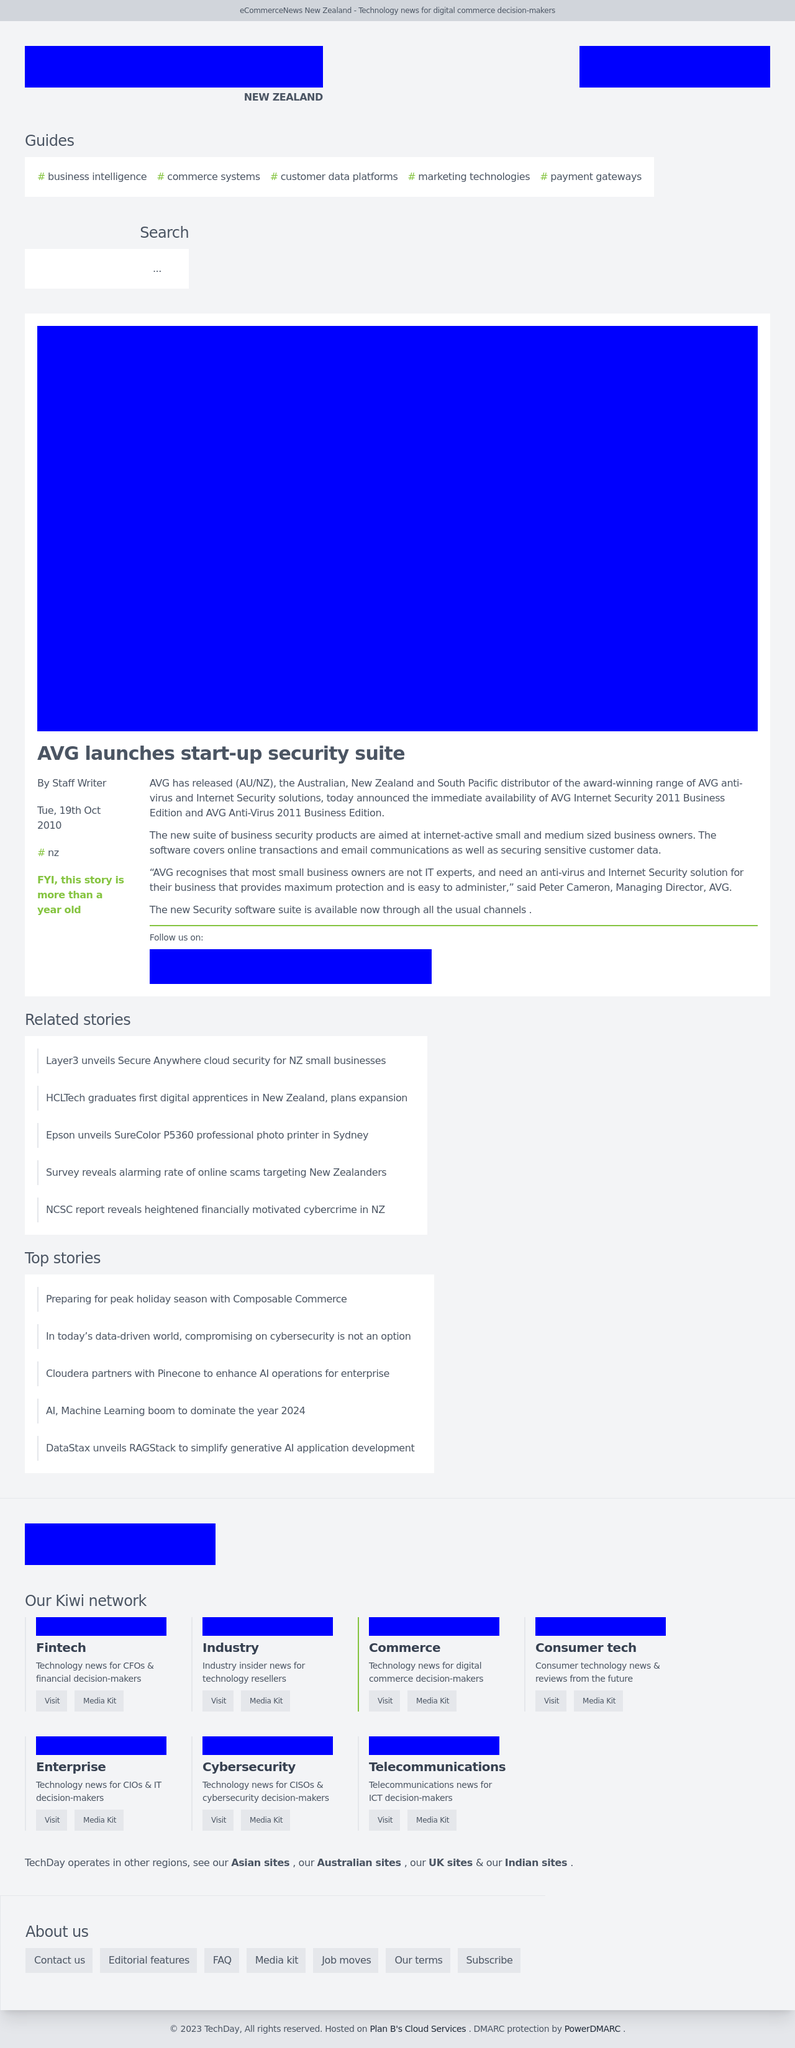What kind of functionality could the search bar on the page offer? The search bar displayed on the page could offer users the ability to quickly find articles, guides, and news stories relevant to their interests. Features may include live search suggestions, filtering by category or date, and a straightforward interface that enhances the usability and accessibility of content within the site, tailored to decision-makers in digital commerce. 